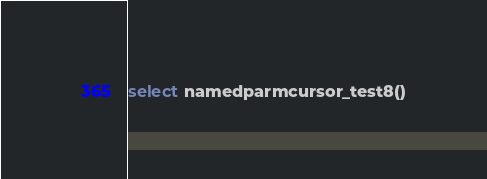Convert code to text. <code><loc_0><loc_0><loc_500><loc_500><_SQL_>select namedparmcursor_test8()
</code> 